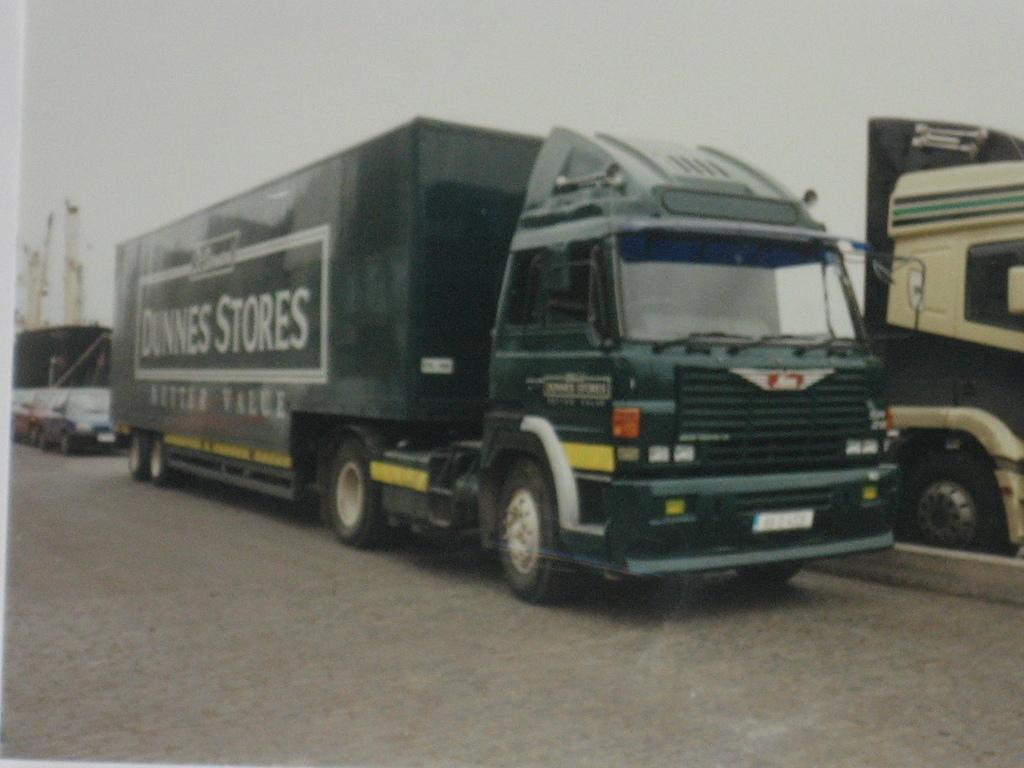What is the main subject of the image? The main subject of the image is a photo of many vehicles. What can be seen in the background of the image? There is a road and a divider of the road in the image. Is there anything on the left side of the image? Yes, there is an object on the left side of the image. Can you see any smoke coming from the vehicles in the image? There is no mention of smoke in the image, so we cannot determine if any smoke is visible. Are there any pears visible in the image? There are no pears present in the image. 